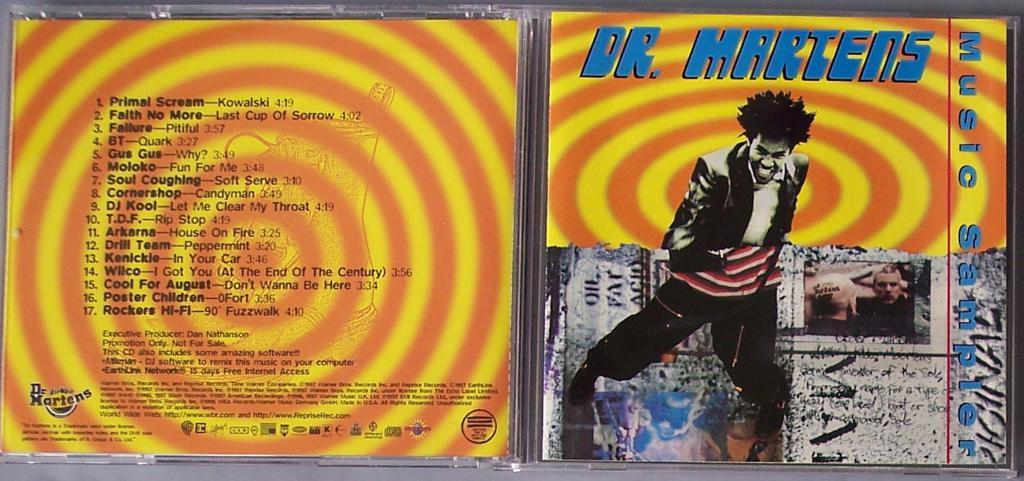What track number is the song called failure?
Offer a terse response. 3. 